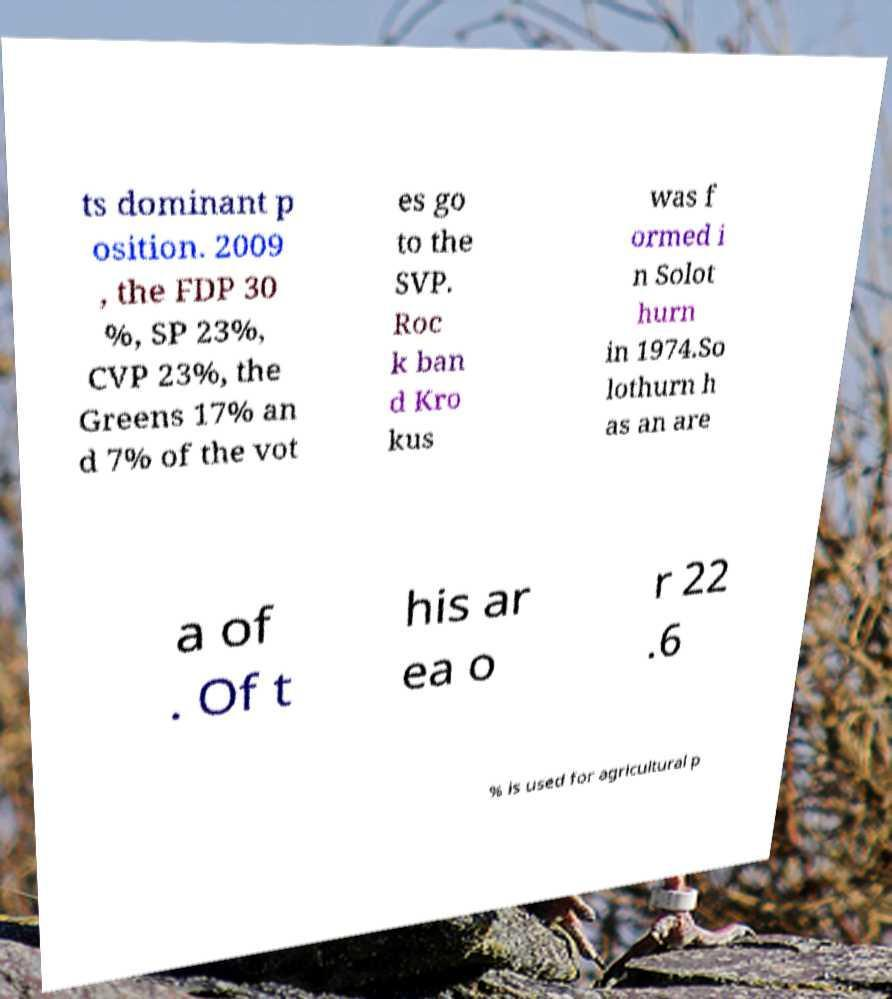There's text embedded in this image that I need extracted. Can you transcribe it verbatim? ts dominant p osition. 2009 , the FDP 30 %, SP 23%, CVP 23%, the Greens 17% an d 7% of the vot es go to the SVP. Roc k ban d Kro kus was f ormed i n Solot hurn in 1974.So lothurn h as an are a of . Of t his ar ea o r 22 .6 % is used for agricultural p 